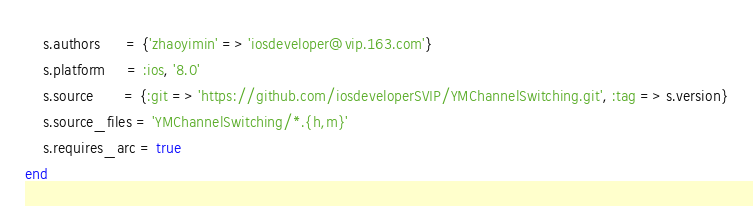Convert code to text. <code><loc_0><loc_0><loc_500><loc_500><_Ruby_>    s.authors      = {'zhaoyimin' => 'iosdeveloper@vip.163.com'}
    s.platform     = :ios, '8.0'
    s.source       = {:git => 'https://github.com/iosdeveloperSVIP/YMChannelSwitching.git', :tag => s.version}
    s.source_files = 'YMChannelSwitching/*.{h,m}'
    s.requires_arc = true
end
</code> 